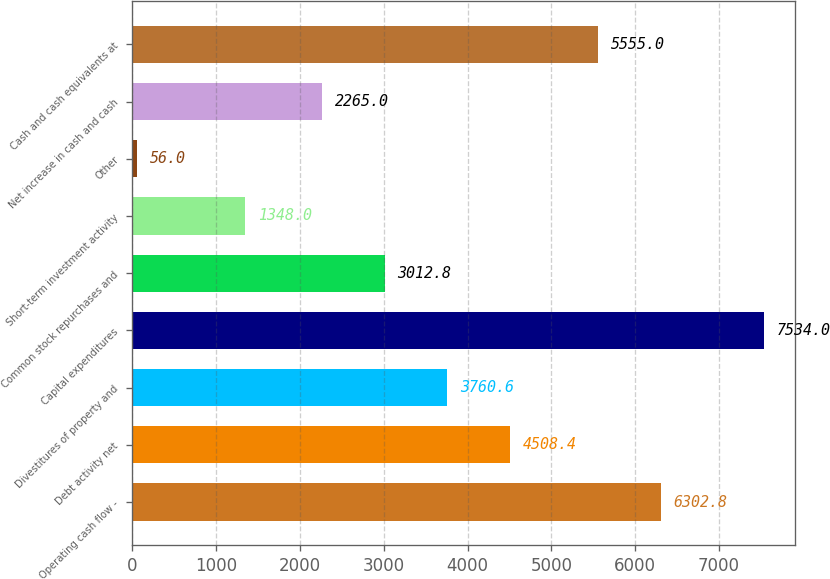Convert chart. <chart><loc_0><loc_0><loc_500><loc_500><bar_chart><fcel>Operating cash flow -<fcel>Debt activity net<fcel>Divestitures of property and<fcel>Capital expenditures<fcel>Common stock repurchases and<fcel>Short-term investment activity<fcel>Other<fcel>Net increase in cash and cash<fcel>Cash and cash equivalents at<nl><fcel>6302.8<fcel>4508.4<fcel>3760.6<fcel>7534<fcel>3012.8<fcel>1348<fcel>56<fcel>2265<fcel>5555<nl></chart> 